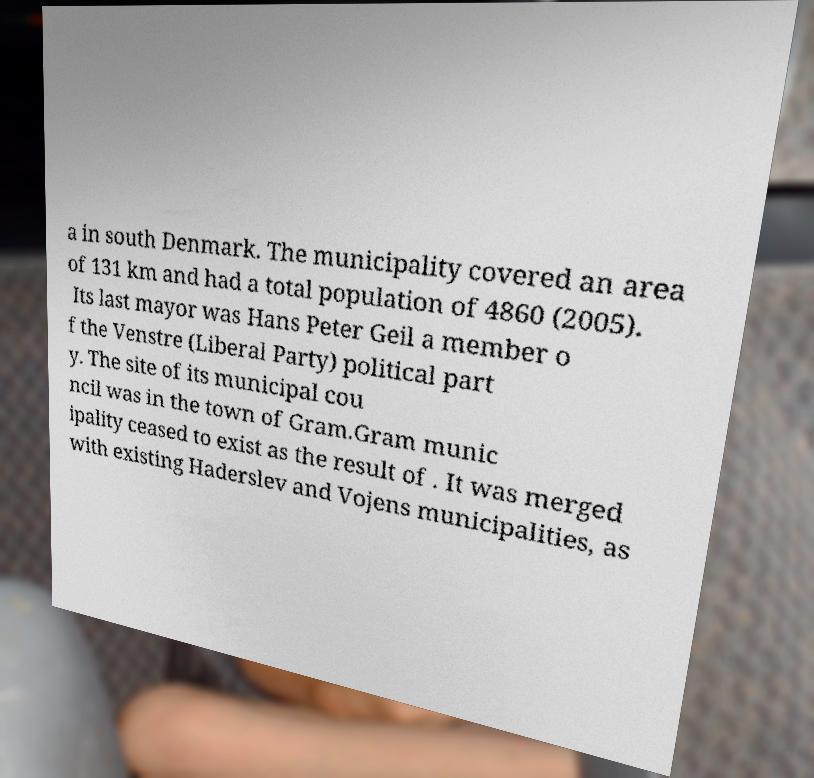Please identify and transcribe the text found in this image. a in south Denmark. The municipality covered an area of 131 km and had a total population of 4860 (2005). Its last mayor was Hans Peter Geil a member o f the Venstre (Liberal Party) political part y. The site of its municipal cou ncil was in the town of Gram.Gram munic ipality ceased to exist as the result of . It was merged with existing Haderslev and Vojens municipalities, as 